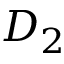Convert formula to latex. <formula><loc_0><loc_0><loc_500><loc_500>D _ { 2 }</formula> 